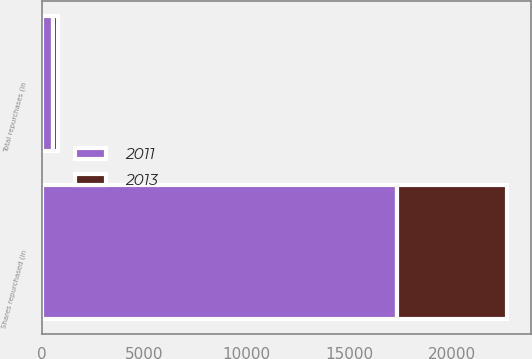Convert chart. <chart><loc_0><loc_0><loc_500><loc_500><stacked_bar_chart><ecel><fcel>Shares repurchased (in<fcel>Total repurchases (in<nl><fcel>2013<fcel>5368<fcel>239<nl><fcel>2011<fcel>17338<fcel>575<nl></chart> 